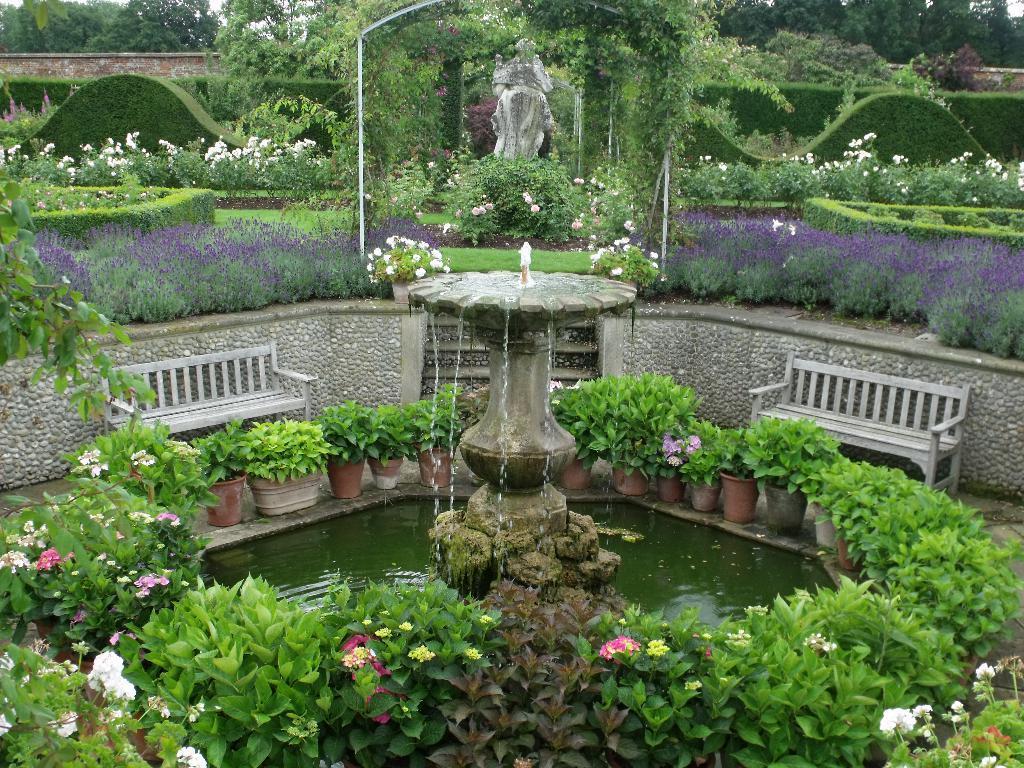Describe this image in one or two sentences. This image consists of a fountain. There are many plants along with flowers. And we can see two benches made up of wood. In the background, there are trees. In the middle, it looks like a sculpture. 